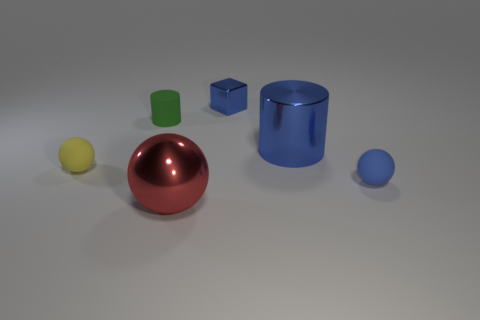Are there any other things that are the same shape as the small metallic object?
Give a very brief answer. No. There is a large object that is the same color as the tiny shiny cube; what material is it?
Give a very brief answer. Metal. Is there a tiny blue object of the same shape as the tiny yellow matte thing?
Give a very brief answer. Yes. There is a shiny cylinder; is it the same color as the rubber object in front of the tiny yellow object?
Ensure brevity in your answer.  Yes. The metal cylinder that is the same color as the small metallic cube is what size?
Your response must be concise. Large. Are there any red things that have the same size as the blue cylinder?
Offer a terse response. Yes. Does the green cylinder have the same material as the red thing that is in front of the blue cylinder?
Offer a very short reply. No. Is the number of big blue shiny cylinders greater than the number of cyan shiny balls?
Provide a succinct answer. Yes. How many cubes are either green objects or large red metallic things?
Provide a short and direct response. 0. The large ball has what color?
Provide a short and direct response. Red. 